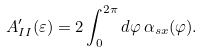Convert formula to latex. <formula><loc_0><loc_0><loc_500><loc_500>A ^ { \prime } _ { I I } ( \varepsilon ) = 2 \int _ { 0 } ^ { 2 \pi } d \varphi \, \alpha _ { s x } ( \varphi ) .</formula> 